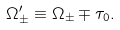<formula> <loc_0><loc_0><loc_500><loc_500>\Omega _ { \pm } ^ { \prime } \equiv \Omega _ { \pm } \mp \tau _ { 0 } .</formula> 